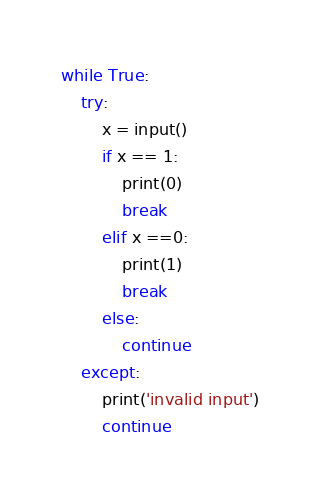Convert code to text. <code><loc_0><loc_0><loc_500><loc_500><_Python_>while True:
  	try:
		x = input()
		if x == 1:
  			print(0)
   			break
        elif x ==0:
            print(1)
            break
        else:
            continue
	except:
      	print('invalid input')
        continue</code> 